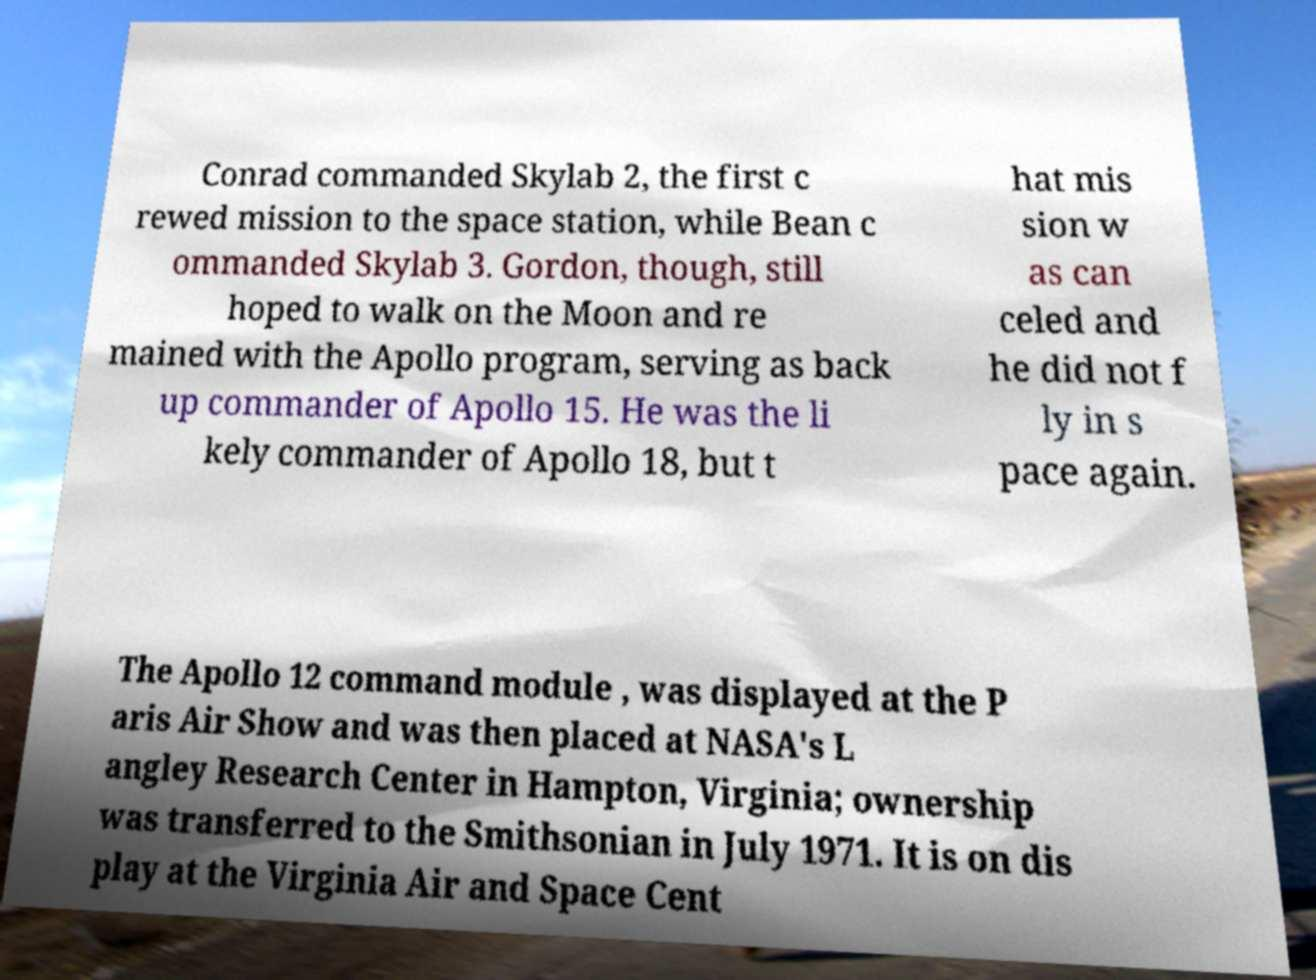Please read and relay the text visible in this image. What does it say? Conrad commanded Skylab 2, the first c rewed mission to the space station, while Bean c ommanded Skylab 3. Gordon, though, still hoped to walk on the Moon and re mained with the Apollo program, serving as back up commander of Apollo 15. He was the li kely commander of Apollo 18, but t hat mis sion w as can celed and he did not f ly in s pace again. The Apollo 12 command module , was displayed at the P aris Air Show and was then placed at NASA's L angley Research Center in Hampton, Virginia; ownership was transferred to the Smithsonian in July 1971. It is on dis play at the Virginia Air and Space Cent 